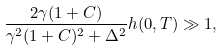<formula> <loc_0><loc_0><loc_500><loc_500>\frac { 2 \gamma ( 1 + C ) } { \gamma ^ { 2 } ( 1 + C ) ^ { 2 } + \Delta ^ { 2 } } h ( 0 , T ) \gg 1 ,</formula> 